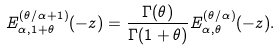<formula> <loc_0><loc_0><loc_500><loc_500>E ^ { ( \theta / \alpha + 1 ) } _ { \alpha , 1 + \theta } ( - z ) = \frac { \Gamma ( \theta ) } { \Gamma ( 1 + \theta ) } E ^ { ( \theta / \alpha ) } _ { \alpha , \theta } ( - z ) .</formula> 